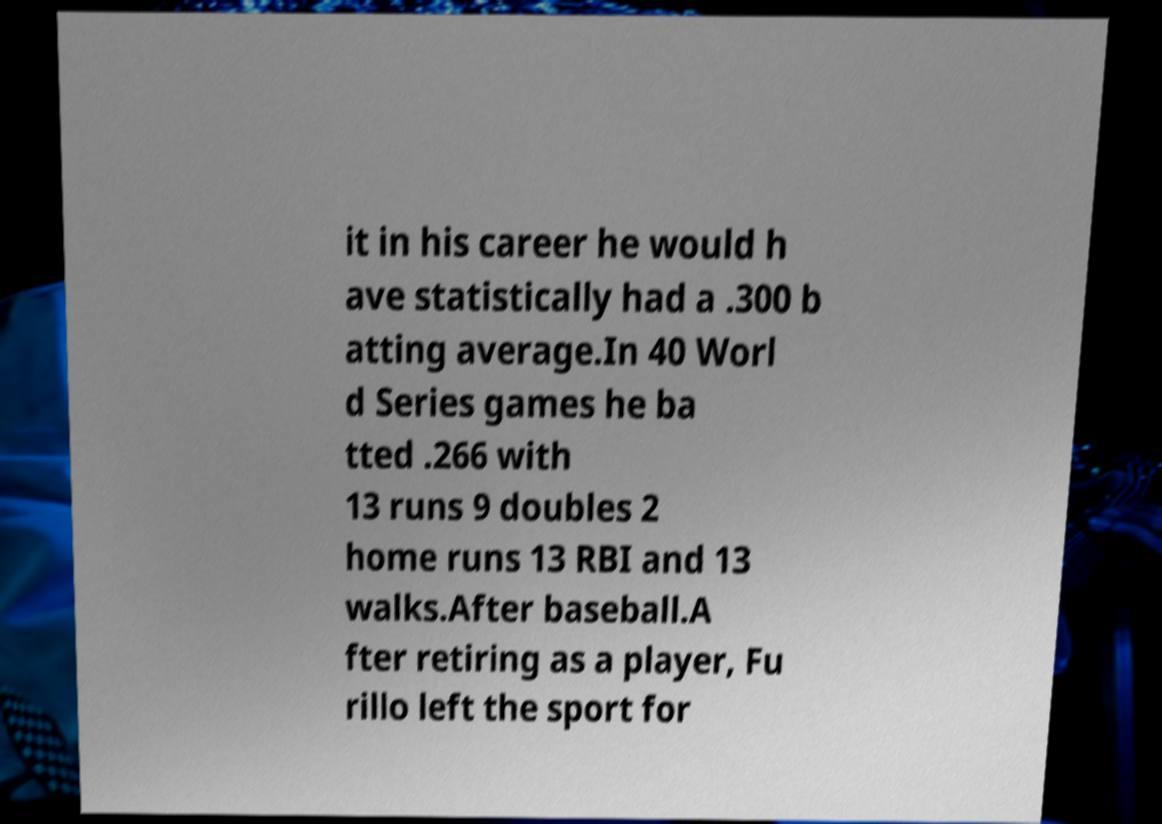Could you extract and type out the text from this image? it in his career he would h ave statistically had a .300 b atting average.In 40 Worl d Series games he ba tted .266 with 13 runs 9 doubles 2 home runs 13 RBI and 13 walks.After baseball.A fter retiring as a player, Fu rillo left the sport for 